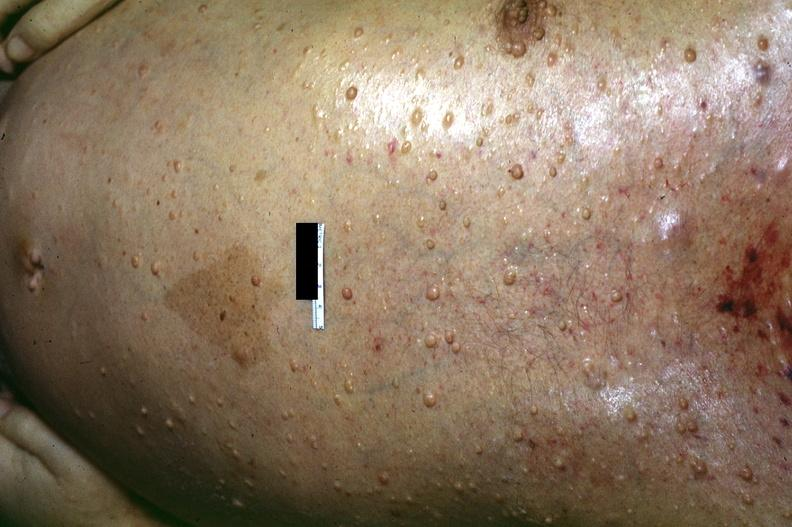does splenomegaly with cirrhosis show skin, neurofibromatosis?
Answer the question using a single word or phrase. No 